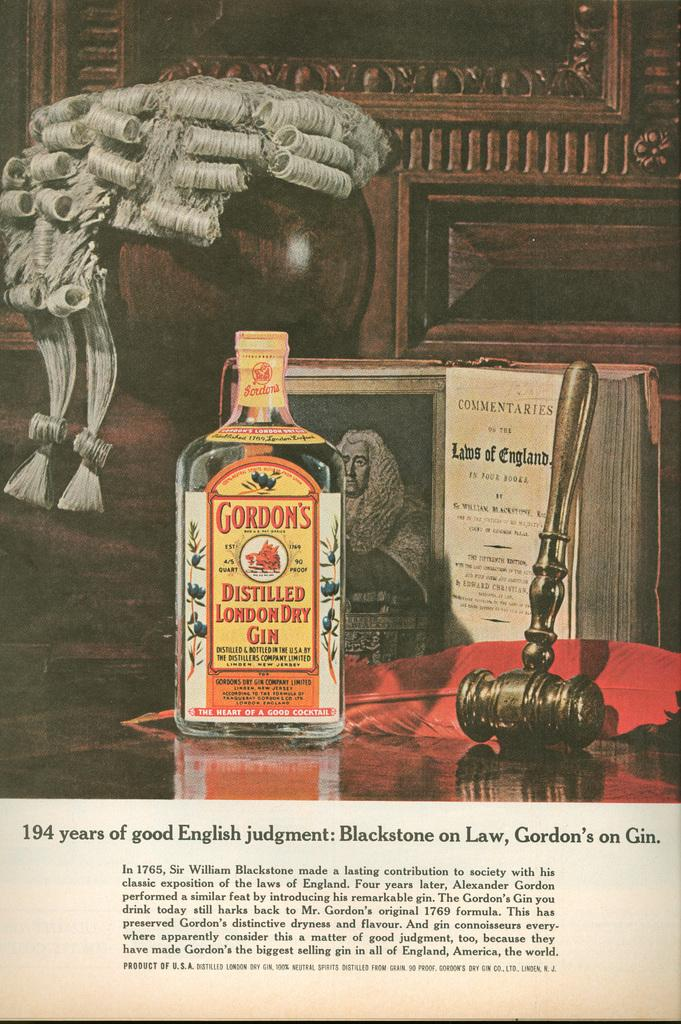<image>
Share a concise interpretation of the image provided. A bottle of Gordons Distilled London Dry Gin sits on a table next to a wig 